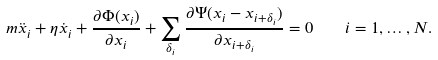<formula> <loc_0><loc_0><loc_500><loc_500>m \ddot { x } _ { i } + \eta \dot { x } _ { i } + \frac { \partial \Phi ( x _ { i } ) } { \partial x _ { i } } + \sum _ { \delta _ { i } } \frac { \partial \Psi ( x _ { i } - x _ { i + \delta _ { i } } ) } { \partial x _ { i + \delta _ { i } } } = 0 \quad i = 1 , \dots , N .</formula> 